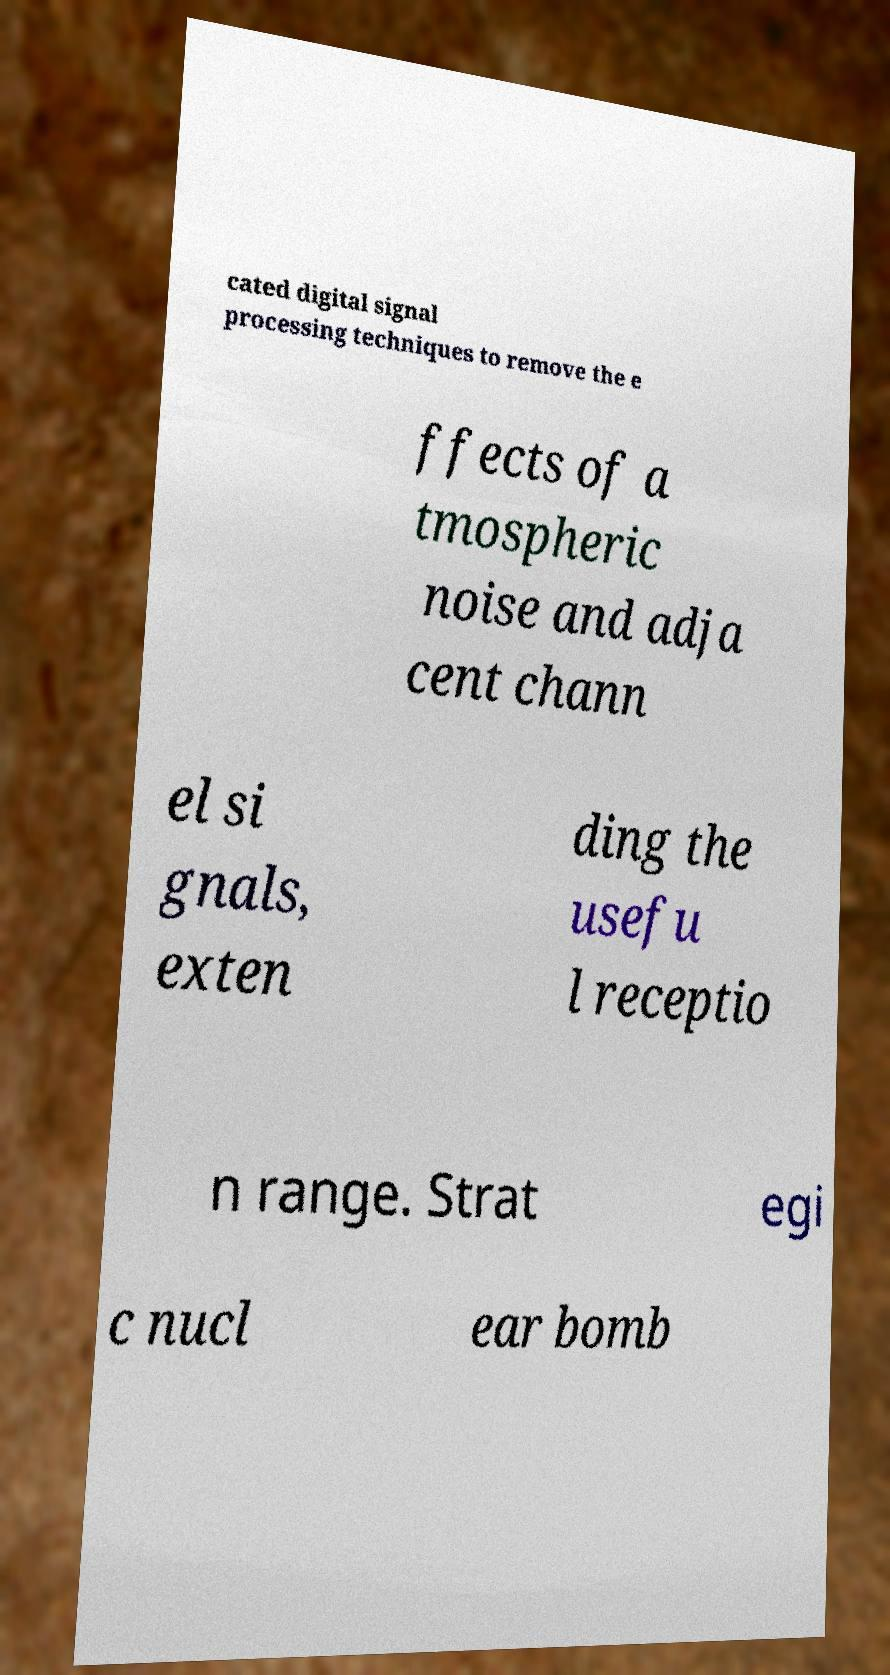Could you extract and type out the text from this image? cated digital signal processing techniques to remove the e ffects of a tmospheric noise and adja cent chann el si gnals, exten ding the usefu l receptio n range. Strat egi c nucl ear bomb 